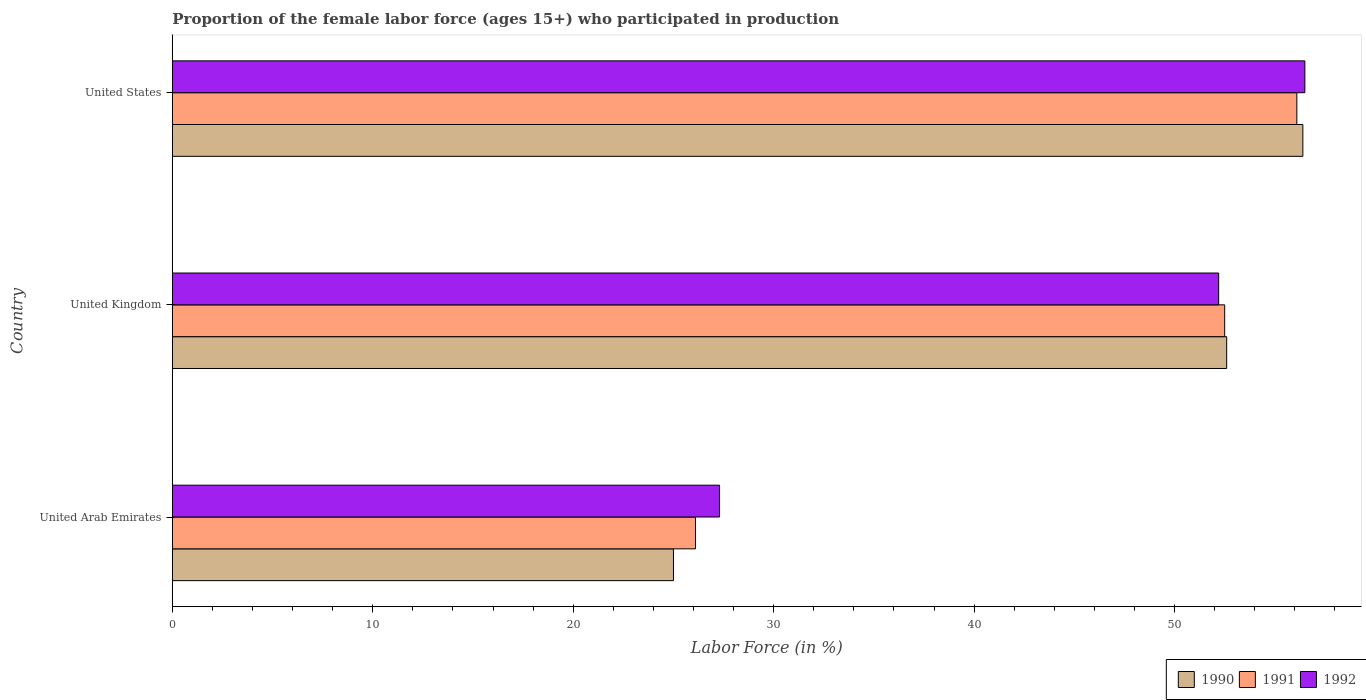How many different coloured bars are there?
Keep it short and to the point. 3. How many groups of bars are there?
Give a very brief answer. 3. Are the number of bars per tick equal to the number of legend labels?
Keep it short and to the point. Yes. How many bars are there on the 2nd tick from the bottom?
Offer a terse response. 3. What is the label of the 3rd group of bars from the top?
Give a very brief answer. United Arab Emirates. What is the proportion of the female labor force who participated in production in 1991 in United Arab Emirates?
Ensure brevity in your answer.  26.1. Across all countries, what is the maximum proportion of the female labor force who participated in production in 1990?
Offer a very short reply. 56.4. In which country was the proportion of the female labor force who participated in production in 1991 maximum?
Give a very brief answer. United States. In which country was the proportion of the female labor force who participated in production in 1991 minimum?
Your answer should be very brief. United Arab Emirates. What is the total proportion of the female labor force who participated in production in 1992 in the graph?
Offer a terse response. 136. What is the difference between the proportion of the female labor force who participated in production in 1990 in United Kingdom and that in United States?
Provide a succinct answer. -3.8. What is the difference between the proportion of the female labor force who participated in production in 1990 in United Arab Emirates and the proportion of the female labor force who participated in production in 1991 in United States?
Offer a very short reply. -31.1. What is the average proportion of the female labor force who participated in production in 1992 per country?
Your response must be concise. 45.33. What is the difference between the proportion of the female labor force who participated in production in 1990 and proportion of the female labor force who participated in production in 1991 in United States?
Keep it short and to the point. 0.3. What is the ratio of the proportion of the female labor force who participated in production in 1990 in United Kingdom to that in United States?
Make the answer very short. 0.93. Is the proportion of the female labor force who participated in production in 1992 in United Kingdom less than that in United States?
Provide a succinct answer. Yes. What is the difference between the highest and the second highest proportion of the female labor force who participated in production in 1992?
Your answer should be very brief. 4.3. What is the difference between the highest and the lowest proportion of the female labor force who participated in production in 1991?
Ensure brevity in your answer.  30. What does the 2nd bar from the top in United Arab Emirates represents?
Your answer should be very brief. 1991. What does the 1st bar from the bottom in United Arab Emirates represents?
Make the answer very short. 1990. Is it the case that in every country, the sum of the proportion of the female labor force who participated in production in 1992 and proportion of the female labor force who participated in production in 1990 is greater than the proportion of the female labor force who participated in production in 1991?
Your answer should be very brief. Yes. Does the graph contain grids?
Your answer should be compact. No. Where does the legend appear in the graph?
Offer a terse response. Bottom right. How many legend labels are there?
Offer a terse response. 3. How are the legend labels stacked?
Your answer should be very brief. Horizontal. What is the title of the graph?
Give a very brief answer. Proportion of the female labor force (ages 15+) who participated in production. What is the Labor Force (in %) in 1991 in United Arab Emirates?
Give a very brief answer. 26.1. What is the Labor Force (in %) in 1992 in United Arab Emirates?
Offer a terse response. 27.3. What is the Labor Force (in %) of 1990 in United Kingdom?
Offer a terse response. 52.6. What is the Labor Force (in %) of 1991 in United Kingdom?
Provide a short and direct response. 52.5. What is the Labor Force (in %) in 1992 in United Kingdom?
Your answer should be very brief. 52.2. What is the Labor Force (in %) in 1990 in United States?
Make the answer very short. 56.4. What is the Labor Force (in %) of 1991 in United States?
Provide a succinct answer. 56.1. What is the Labor Force (in %) of 1992 in United States?
Provide a succinct answer. 56.5. Across all countries, what is the maximum Labor Force (in %) in 1990?
Provide a short and direct response. 56.4. Across all countries, what is the maximum Labor Force (in %) in 1991?
Offer a very short reply. 56.1. Across all countries, what is the maximum Labor Force (in %) of 1992?
Your response must be concise. 56.5. Across all countries, what is the minimum Labor Force (in %) in 1991?
Offer a terse response. 26.1. Across all countries, what is the minimum Labor Force (in %) of 1992?
Provide a succinct answer. 27.3. What is the total Labor Force (in %) in 1990 in the graph?
Your answer should be compact. 134. What is the total Labor Force (in %) in 1991 in the graph?
Give a very brief answer. 134.7. What is the total Labor Force (in %) of 1992 in the graph?
Offer a very short reply. 136. What is the difference between the Labor Force (in %) in 1990 in United Arab Emirates and that in United Kingdom?
Your answer should be very brief. -27.6. What is the difference between the Labor Force (in %) in 1991 in United Arab Emirates and that in United Kingdom?
Ensure brevity in your answer.  -26.4. What is the difference between the Labor Force (in %) in 1992 in United Arab Emirates and that in United Kingdom?
Give a very brief answer. -24.9. What is the difference between the Labor Force (in %) in 1990 in United Arab Emirates and that in United States?
Keep it short and to the point. -31.4. What is the difference between the Labor Force (in %) of 1991 in United Arab Emirates and that in United States?
Your answer should be very brief. -30. What is the difference between the Labor Force (in %) of 1992 in United Arab Emirates and that in United States?
Give a very brief answer. -29.2. What is the difference between the Labor Force (in %) in 1990 in United Kingdom and that in United States?
Your answer should be compact. -3.8. What is the difference between the Labor Force (in %) in 1991 in United Kingdom and that in United States?
Offer a terse response. -3.6. What is the difference between the Labor Force (in %) in 1992 in United Kingdom and that in United States?
Ensure brevity in your answer.  -4.3. What is the difference between the Labor Force (in %) in 1990 in United Arab Emirates and the Labor Force (in %) in 1991 in United Kingdom?
Make the answer very short. -27.5. What is the difference between the Labor Force (in %) in 1990 in United Arab Emirates and the Labor Force (in %) in 1992 in United Kingdom?
Keep it short and to the point. -27.2. What is the difference between the Labor Force (in %) in 1991 in United Arab Emirates and the Labor Force (in %) in 1992 in United Kingdom?
Provide a succinct answer. -26.1. What is the difference between the Labor Force (in %) of 1990 in United Arab Emirates and the Labor Force (in %) of 1991 in United States?
Your answer should be compact. -31.1. What is the difference between the Labor Force (in %) in 1990 in United Arab Emirates and the Labor Force (in %) in 1992 in United States?
Offer a terse response. -31.5. What is the difference between the Labor Force (in %) of 1991 in United Arab Emirates and the Labor Force (in %) of 1992 in United States?
Keep it short and to the point. -30.4. What is the difference between the Labor Force (in %) in 1990 in United Kingdom and the Labor Force (in %) in 1991 in United States?
Offer a very short reply. -3.5. What is the difference between the Labor Force (in %) of 1991 in United Kingdom and the Labor Force (in %) of 1992 in United States?
Make the answer very short. -4. What is the average Labor Force (in %) in 1990 per country?
Your answer should be very brief. 44.67. What is the average Labor Force (in %) in 1991 per country?
Make the answer very short. 44.9. What is the average Labor Force (in %) in 1992 per country?
Your response must be concise. 45.33. What is the difference between the Labor Force (in %) in 1990 and Labor Force (in %) in 1991 in United Arab Emirates?
Make the answer very short. -1.1. What is the difference between the Labor Force (in %) in 1990 and Labor Force (in %) in 1992 in United Arab Emirates?
Provide a succinct answer. -2.3. What is the difference between the Labor Force (in %) in 1990 and Labor Force (in %) in 1991 in United Kingdom?
Ensure brevity in your answer.  0.1. What is the difference between the Labor Force (in %) of 1990 and Labor Force (in %) of 1992 in United Kingdom?
Your answer should be very brief. 0.4. What is the difference between the Labor Force (in %) in 1991 and Labor Force (in %) in 1992 in United Kingdom?
Make the answer very short. 0.3. What is the difference between the Labor Force (in %) in 1990 and Labor Force (in %) in 1991 in United States?
Your response must be concise. 0.3. What is the difference between the Labor Force (in %) in 1990 and Labor Force (in %) in 1992 in United States?
Your answer should be very brief. -0.1. What is the ratio of the Labor Force (in %) in 1990 in United Arab Emirates to that in United Kingdom?
Provide a short and direct response. 0.48. What is the ratio of the Labor Force (in %) of 1991 in United Arab Emirates to that in United Kingdom?
Make the answer very short. 0.5. What is the ratio of the Labor Force (in %) of 1992 in United Arab Emirates to that in United Kingdom?
Offer a very short reply. 0.52. What is the ratio of the Labor Force (in %) in 1990 in United Arab Emirates to that in United States?
Ensure brevity in your answer.  0.44. What is the ratio of the Labor Force (in %) of 1991 in United Arab Emirates to that in United States?
Provide a short and direct response. 0.47. What is the ratio of the Labor Force (in %) of 1992 in United Arab Emirates to that in United States?
Offer a very short reply. 0.48. What is the ratio of the Labor Force (in %) in 1990 in United Kingdom to that in United States?
Give a very brief answer. 0.93. What is the ratio of the Labor Force (in %) of 1991 in United Kingdom to that in United States?
Your answer should be compact. 0.94. What is the ratio of the Labor Force (in %) in 1992 in United Kingdom to that in United States?
Your answer should be compact. 0.92. What is the difference between the highest and the second highest Labor Force (in %) of 1990?
Provide a short and direct response. 3.8. What is the difference between the highest and the second highest Labor Force (in %) in 1991?
Offer a very short reply. 3.6. What is the difference between the highest and the second highest Labor Force (in %) of 1992?
Give a very brief answer. 4.3. What is the difference between the highest and the lowest Labor Force (in %) of 1990?
Your answer should be very brief. 31.4. What is the difference between the highest and the lowest Labor Force (in %) in 1992?
Your response must be concise. 29.2. 